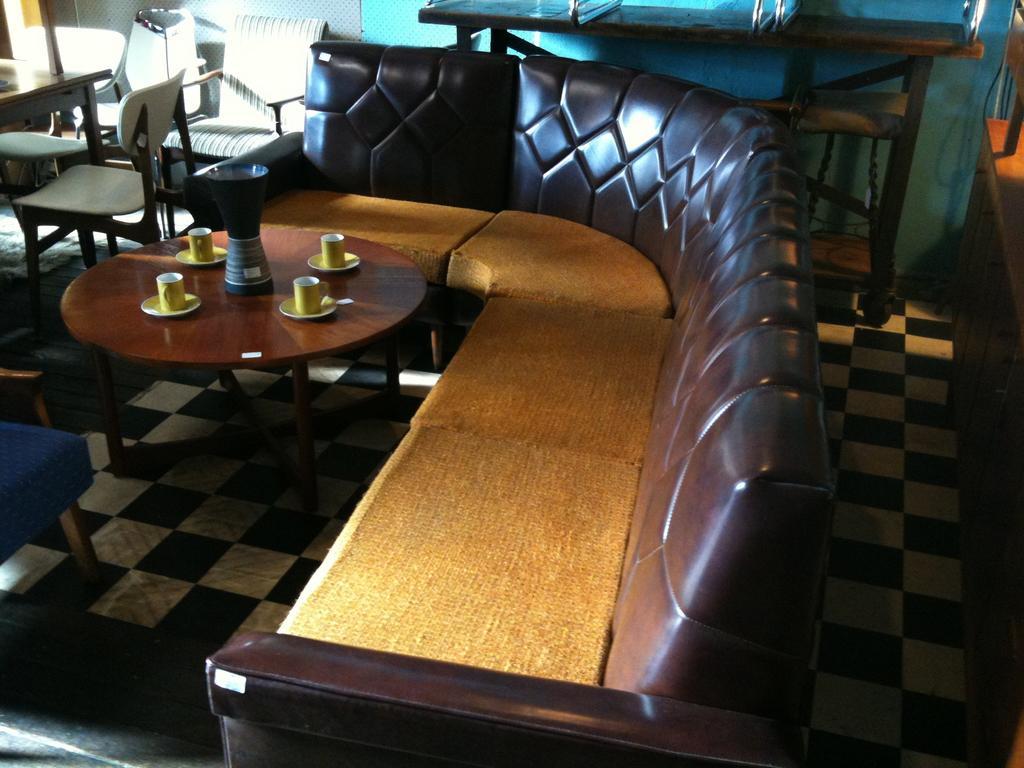Could you give a brief overview of what you see in this image? This picture shows a sofa bed and we see cups flask on the table 